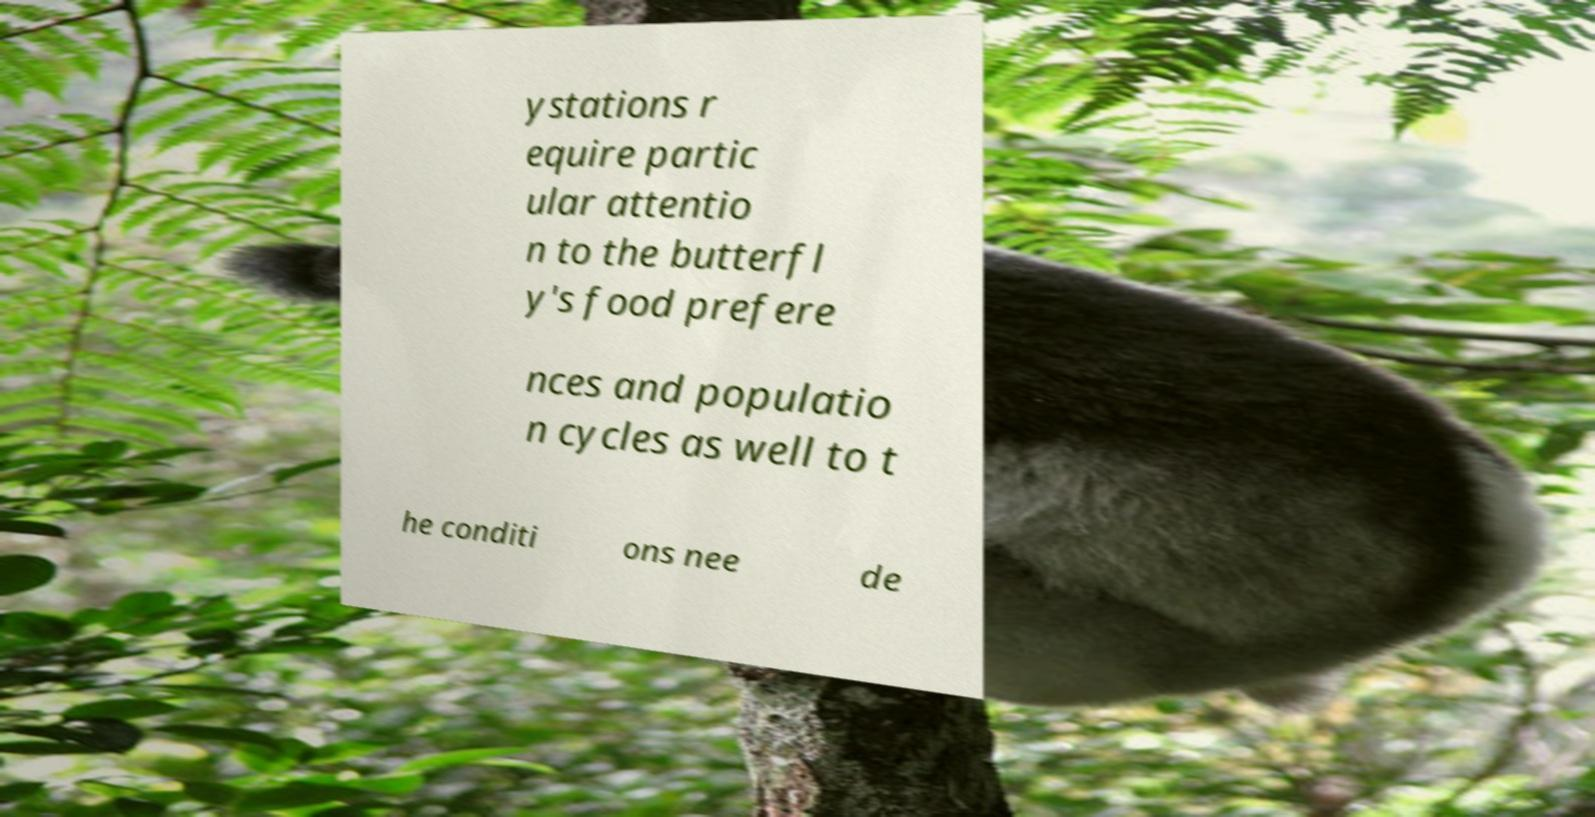I need the written content from this picture converted into text. Can you do that? ystations r equire partic ular attentio n to the butterfl y's food prefere nces and populatio n cycles as well to t he conditi ons nee de 